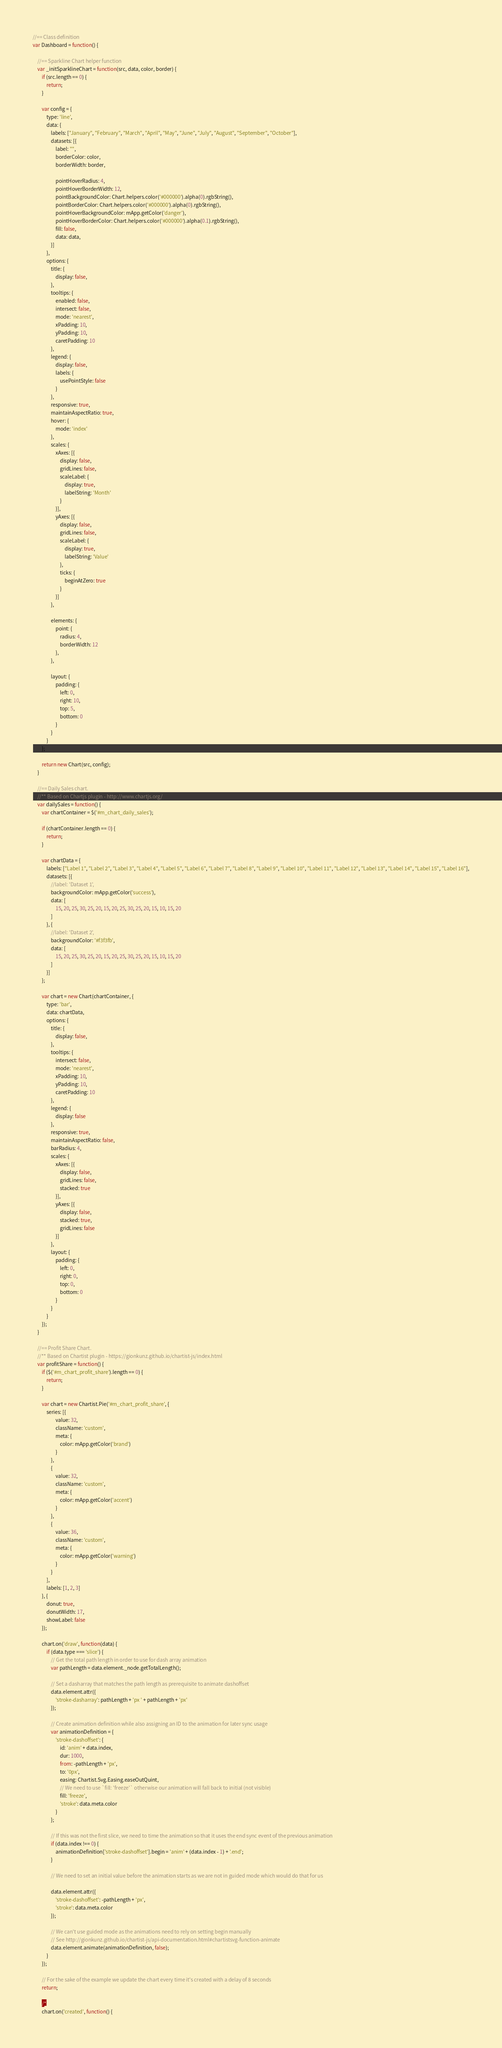<code> <loc_0><loc_0><loc_500><loc_500><_JavaScript_>//== Class definition
var Dashboard = function() {

    //== Sparkline Chart helper function
    var _initSparklineChart = function(src, data, color, border) {
        if (src.length == 0) {
            return;
        }

        var config = {
            type: 'line',
            data: {
                labels: ["January", "February", "March", "April", "May", "June", "July", "August", "September", "October"],
                datasets: [{
                    label: "",
                    borderColor: color,
                    borderWidth: border,

                    pointHoverRadius: 4,
                    pointHoverBorderWidth: 12,
                    pointBackgroundColor: Chart.helpers.color('#000000').alpha(0).rgbString(),
                    pointBorderColor: Chart.helpers.color('#000000').alpha(0).rgbString(),
                    pointHoverBackgroundColor: mApp.getColor('danger'),
                    pointHoverBorderColor: Chart.helpers.color('#000000').alpha(0.1).rgbString(),
                    fill: false,
                    data: data,
                }]
            },
            options: {
                title: {
                    display: false,
                },
                tooltips: {
                    enabled: false,
                    intersect: false,
                    mode: 'nearest',
                    xPadding: 10,
                    yPadding: 10,
                    caretPadding: 10
                },
                legend: {
                    display: false,
                    labels: {
                        usePointStyle: false
                    }
                },
                responsive: true,
                maintainAspectRatio: true,
                hover: {
                    mode: 'index'
                },
                scales: {
                    xAxes: [{
                        display: false,
                        gridLines: false,
                        scaleLabel: {
                            display: true,
                            labelString: 'Month'
                        }
                    }],
                    yAxes: [{
                        display: false,
                        gridLines: false,
                        scaleLabel: {
                            display: true,
                            labelString: 'Value'
                        },
                        ticks: {
                            beginAtZero: true
                        }
                    }]
                },

                elements: {
                    point: {
                        radius: 4,
                        borderWidth: 12
                    },
                },

                layout: {
                    padding: {
                        left: 0,
                        right: 10,
                        top: 5,
                        bottom: 0
                    }
                }
            }
        };

        return new Chart(src, config);
    }

    //== Daily Sales chart.
    //** Based on Chartjs plugin - http://www.chartjs.org/
    var dailySales = function() {
        var chartContainer = $('#m_chart_daily_sales');

        if (chartContainer.length == 0) {
            return;
        }

        var chartData = {
            labels: ["Label 1", "Label 2", "Label 3", "Label 4", "Label 5", "Label 6", "Label 7", "Label 8", "Label 9", "Label 10", "Label 11", "Label 12", "Label 13", "Label 14", "Label 15", "Label 16"],
            datasets: [{
                //label: 'Dataset 1',
                backgroundColor: mApp.getColor('success'),
                data: [
                    15, 20, 25, 30, 25, 20, 15, 20, 25, 30, 25, 20, 15, 10, 15, 20
                ]
            }, {
                //label: 'Dataset 2',
                backgroundColor: '#f3f3fb',
                data: [
                    15, 20, 25, 30, 25, 20, 15, 20, 25, 30, 25, 20, 15, 10, 15, 20
                ]
            }]
        };

        var chart = new Chart(chartContainer, {
            type: 'bar',
            data: chartData,
            options: {
                title: {
                    display: false,
                },
                tooltips: {
                    intersect: false,
                    mode: 'nearest',
                    xPadding: 10,
                    yPadding: 10,
                    caretPadding: 10
                },
                legend: {
                    display: false
                },
                responsive: true,
                maintainAspectRatio: false,
                barRadius: 4,
                scales: {
                    xAxes: [{
                        display: false,
                        gridLines: false,
                        stacked: true
                    }],
                    yAxes: [{
                        display: false,
                        stacked: true,
                        gridLines: false
                    }]
                },
                layout: {
                    padding: {
                        left: 0,
                        right: 0,
                        top: 0,
                        bottom: 0
                    }
                }
            }
        });
    }

    //== Profit Share Chart.
    //** Based on Chartist plugin - https://gionkunz.github.io/chartist-js/index.html
    var profitShare = function() {
        if ($('#m_chart_profit_share').length == 0) {
            return;
        }

        var chart = new Chartist.Pie('#m_chart_profit_share', {
            series: [{
                    value: 32,
                    className: 'custom',
                    meta: {
                        color: mApp.getColor('brand')
                    }
                },
                {
                    value: 32,
                    className: 'custom',
                    meta: {
                        color: mApp.getColor('accent')
                    }
                },
                {
                    value: 36,
                    className: 'custom',
                    meta: {
                        color: mApp.getColor('warning')
                    }
                }
            ],
            labels: [1, 2, 3]
        }, {
            donut: true,
            donutWidth: 17,
            showLabel: false
        });

        chart.on('draw', function(data) {
            if (data.type === 'slice') {
                // Get the total path length in order to use for dash array animation
                var pathLength = data.element._node.getTotalLength();

                // Set a dasharray that matches the path length as prerequisite to animate dashoffset
                data.element.attr({
                    'stroke-dasharray': pathLength + 'px ' + pathLength + 'px'
                });

                // Create animation definition while also assigning an ID to the animation for later sync usage
                var animationDefinition = {
                    'stroke-dashoffset': {
                        id: 'anim' + data.index,
                        dur: 1000,
                        from: -pathLength + 'px',
                        to: '0px',
                        easing: Chartist.Svg.Easing.easeOutQuint,
                        // We need to use `fill: 'freeze'` otherwise our animation will fall back to initial (not visible)
                        fill: 'freeze',
                        'stroke': data.meta.color
                    }
                };

                // If this was not the first slice, we need to time the animation so that it uses the end sync event of the previous animation
                if (data.index !== 0) {
                    animationDefinition['stroke-dashoffset'].begin = 'anim' + (data.index - 1) + '.end';
                }

                // We need to set an initial value before the animation starts as we are not in guided mode which would do that for us

                data.element.attr({
                    'stroke-dashoffset': -pathLength + 'px',
                    'stroke': data.meta.color
                });

                // We can't use guided mode as the animations need to rely on setting begin manually
                // See http://gionkunz.github.io/chartist-js/api-documentation.html#chartistsvg-function-animate
                data.element.animate(animationDefinition, false);
            }
        });

        // For the sake of the example we update the chart every time it's created with a delay of 8 seconds
        return;
        
        /*
        chart.on('created', function() {</code> 